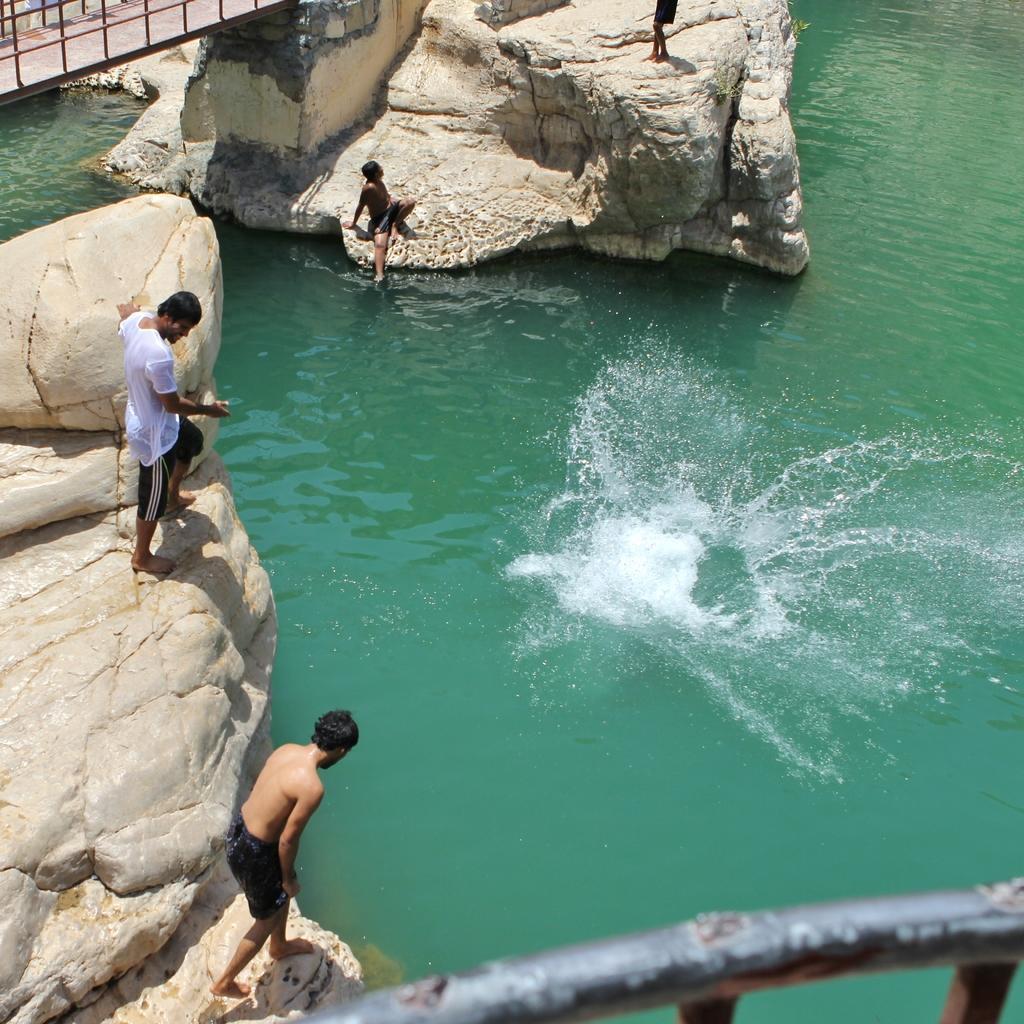Describe this image in one or two sentences. In this picture I can observe some people standing on the rocks. I can observe a pond in this picture. There is a railing on the top left side. 